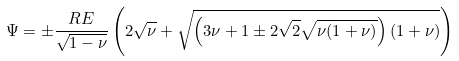<formula> <loc_0><loc_0><loc_500><loc_500>\Psi = \pm \frac { R E } { \sqrt { 1 - \nu } } \left ( 2 \sqrt { \nu } + \sqrt { \left ( 3 \nu + 1 \pm 2 \sqrt { 2 } \sqrt { \nu ( 1 + \nu ) } \right ) \left ( 1 + \nu \right ) } \right )</formula> 